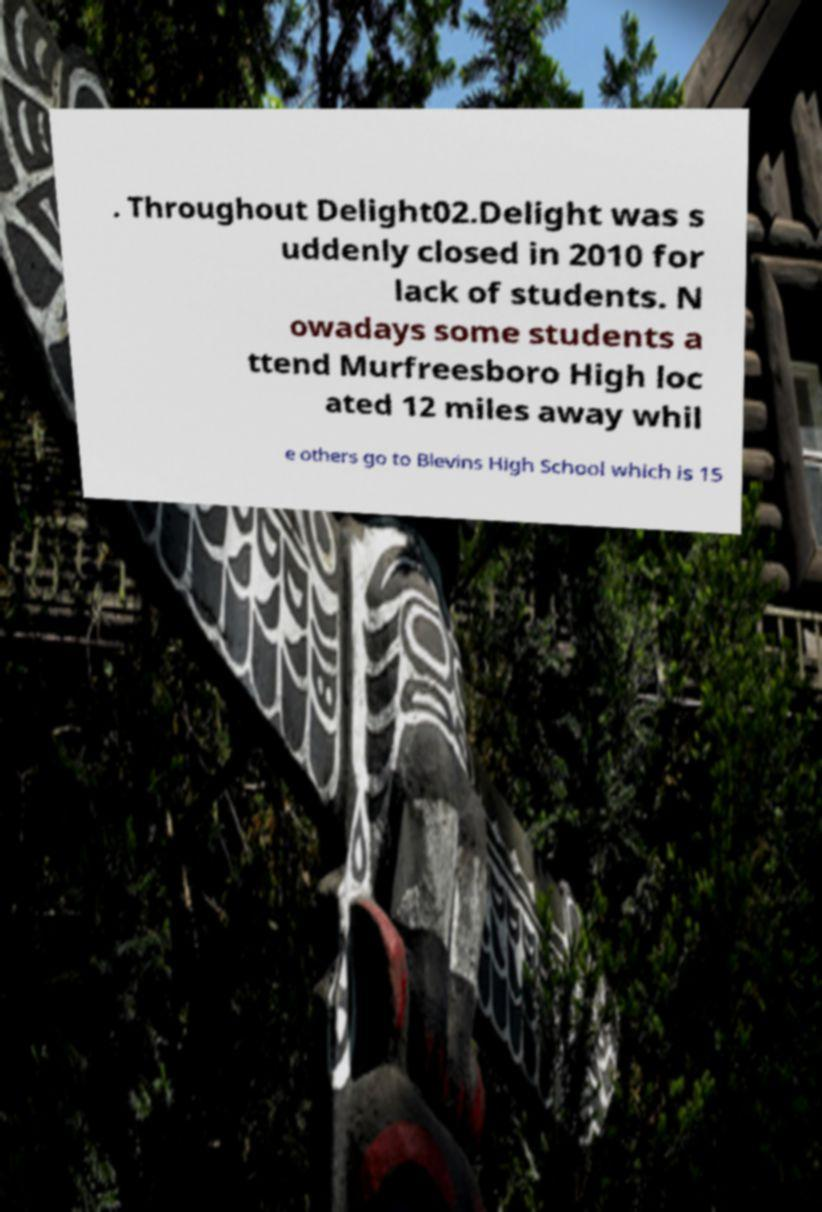For documentation purposes, I need the text within this image transcribed. Could you provide that? . Throughout Delight02.Delight was s uddenly closed in 2010 for lack of students. N owadays some students a ttend Murfreesboro High loc ated 12 miles away whil e others go to Blevins High School which is 15 